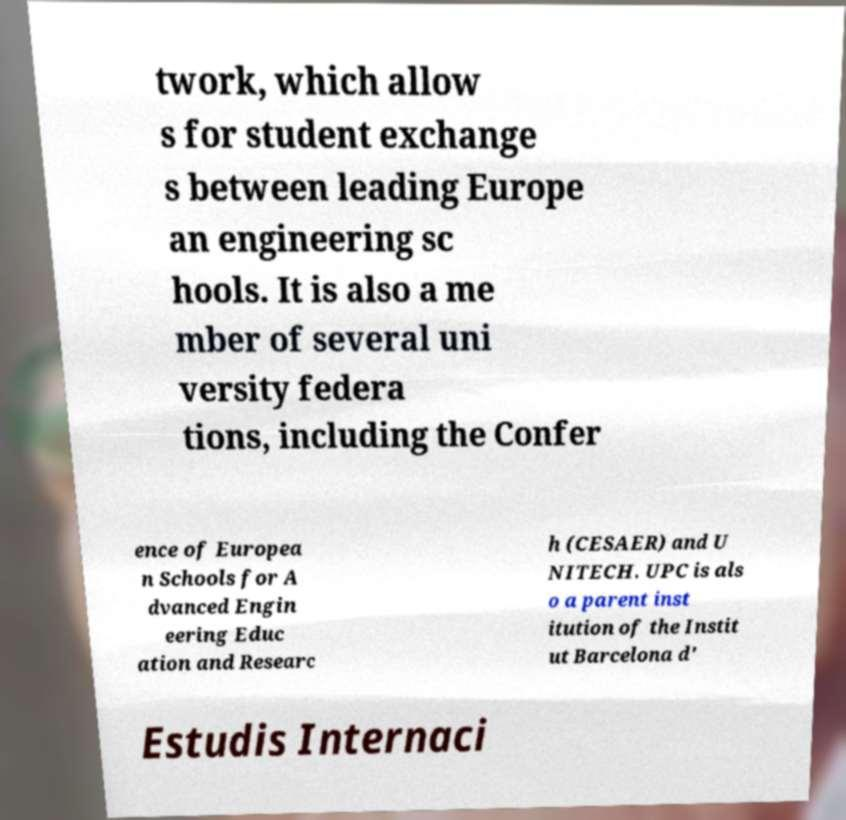Please identify and transcribe the text found in this image. twork, which allow s for student exchange s between leading Europe an engineering sc hools. It is also a me mber of several uni versity federa tions, including the Confer ence of Europea n Schools for A dvanced Engin eering Educ ation and Researc h (CESAER) and U NITECH. UPC is als o a parent inst itution of the Instit ut Barcelona d' Estudis Internaci 